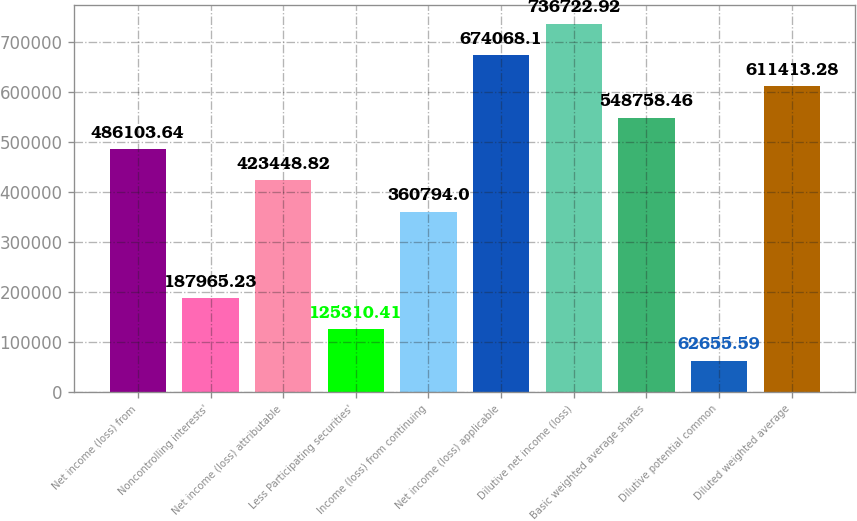Convert chart. <chart><loc_0><loc_0><loc_500><loc_500><bar_chart><fcel>Net income (loss) from<fcel>Noncontrolling interests'<fcel>Net income (loss) attributable<fcel>Less Participating securities'<fcel>Income (loss) from continuing<fcel>Net income (loss) applicable<fcel>Dilutive net income (loss)<fcel>Basic weighted average shares<fcel>Dilutive potential common<fcel>Diluted weighted average<nl><fcel>486104<fcel>187965<fcel>423449<fcel>125310<fcel>360794<fcel>674068<fcel>736723<fcel>548758<fcel>62655.6<fcel>611413<nl></chart> 